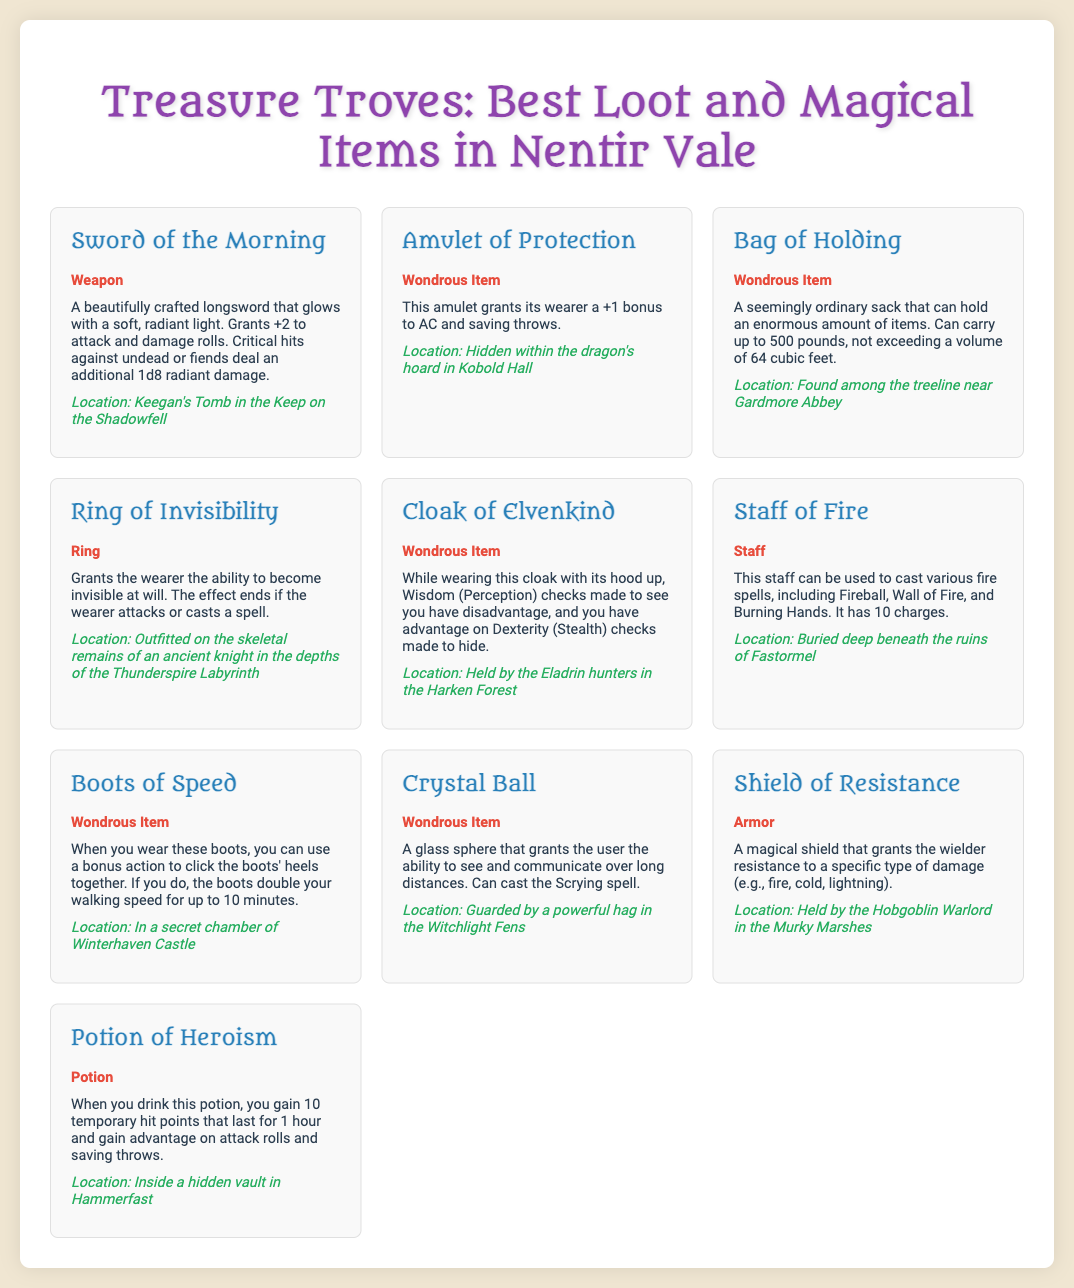What is the name of the weapon that grants +2 to attack and damage rolls? The document mentions the "Sword of the Morning" as the weapon that grants +2 to attack and damage rolls.
Answer: Sword of the Morning Where can the Amulet of Protection be found? According to the document, the Amulet of Protection is hidden within the dragon's hoard in Kobold Hall.
Answer: Kobold Hall What is the type of the Bag of Holding? The document lists the Bag of Holding as a "Wondrous Item."
Answer: Wondrous Item How many charges does the Staff of Fire have? The document states that the Staff of Fire has 10 charges.
Answer: 10 Which item grants resistance to a specific type of damage? The "Shield of Resistance" is the item that grants resistance to a specific type of damage.
Answer: Shield of Resistance What effect does the Ring of Invisibility have? The Ring of Invisibility grants the wearer the ability to become invisible at will.
Answer: Become invisible at will How do the Boots of Speed enhance movement? The Boots of Speed double the walking speed for up to 10 minutes.
Answer: Double the walking speed Which item is guarded by a powerful hag? A "Crystal Ball" is guarded by a powerful hag in the Witchlight Fens.
Answer: Crystal Ball What bonus does the Potion of Heroism provide? The Potion of Heroism grants 10 temporary hit points and advantage on attack rolls and saving throws.
Answer: 10 temporary hit points and advantage on attack rolls and saving throws 